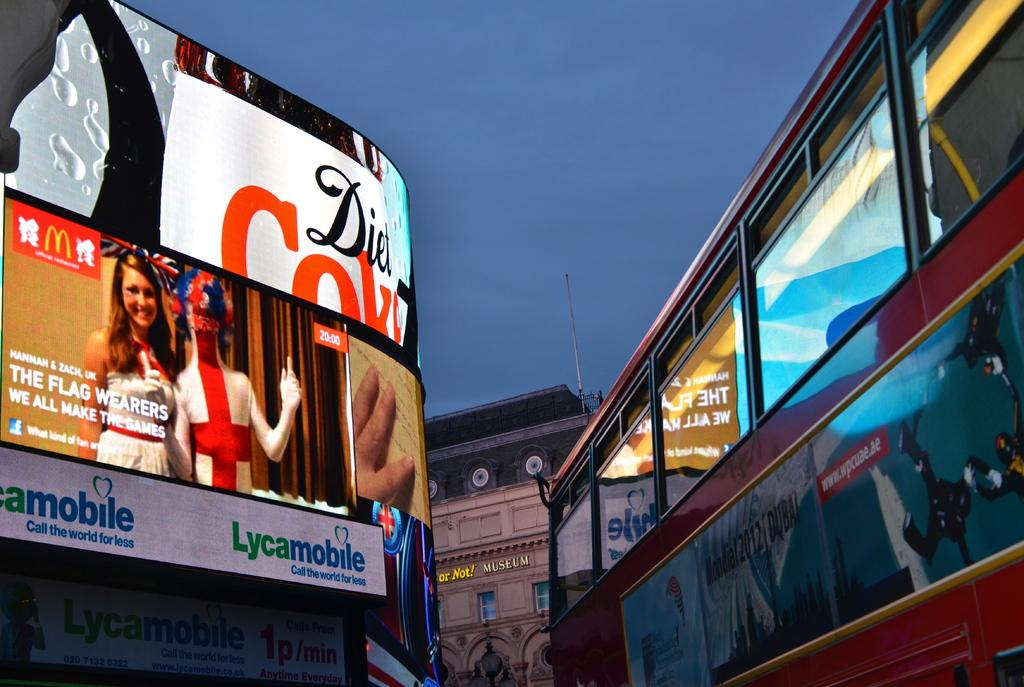<image>
Write a terse but informative summary of the picture. A Diet Coke billboard lights up in the dusk. 